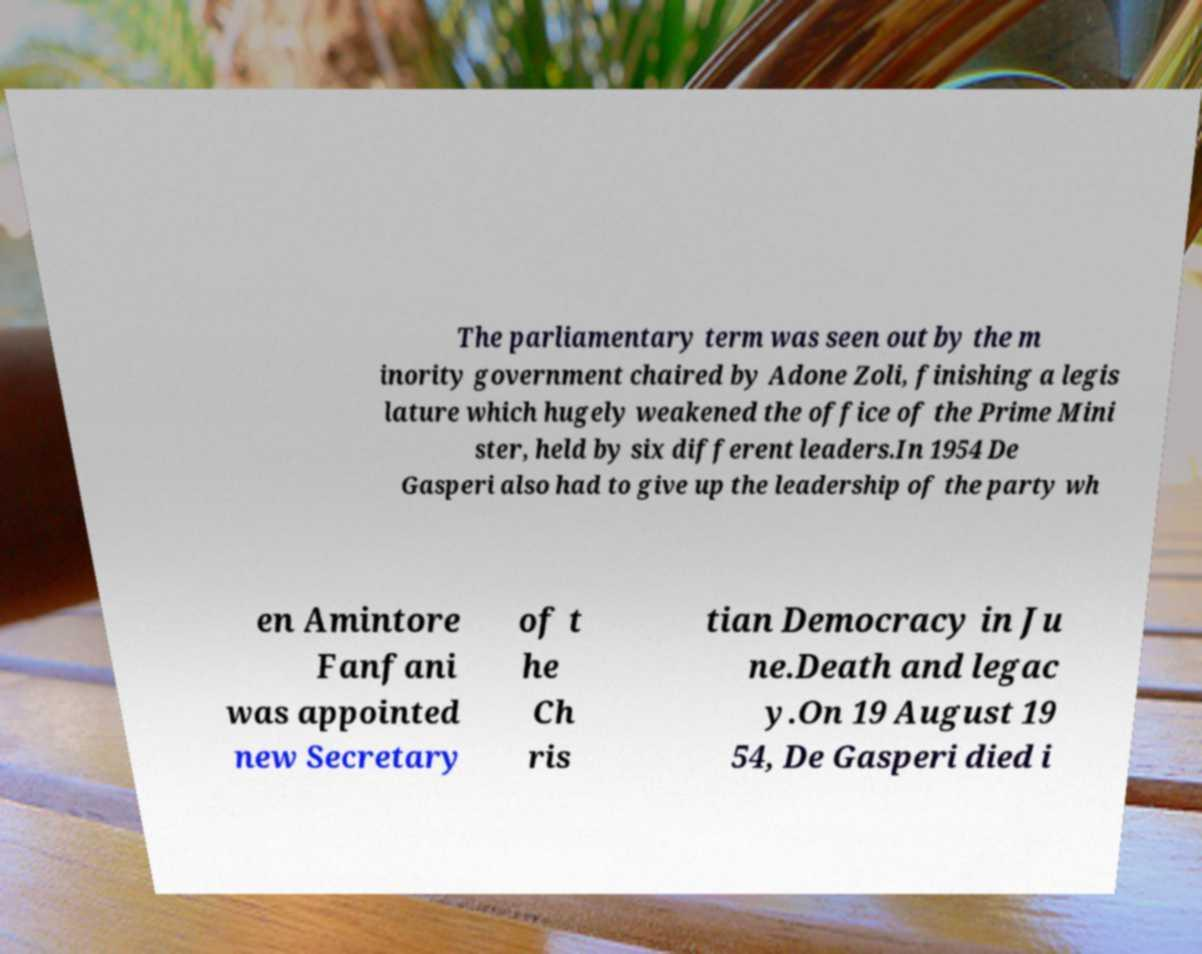Please identify and transcribe the text found in this image. The parliamentary term was seen out by the m inority government chaired by Adone Zoli, finishing a legis lature which hugely weakened the office of the Prime Mini ster, held by six different leaders.In 1954 De Gasperi also had to give up the leadership of the party wh en Amintore Fanfani was appointed new Secretary of t he Ch ris tian Democracy in Ju ne.Death and legac y.On 19 August 19 54, De Gasperi died i 